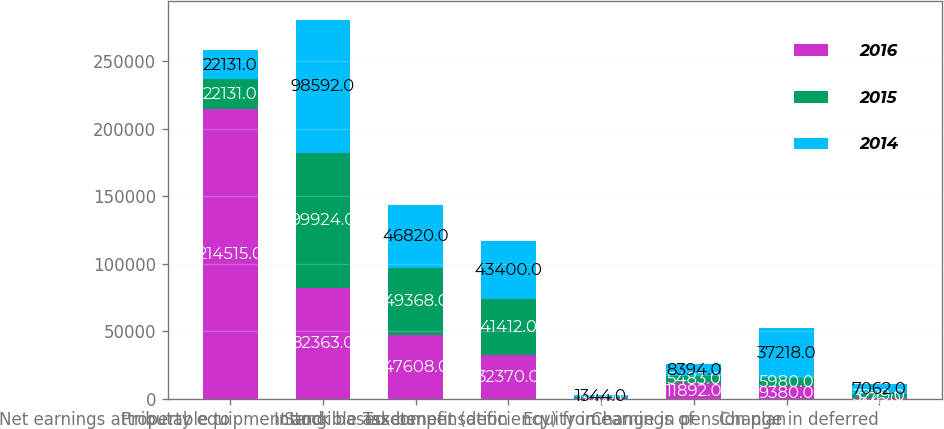<chart> <loc_0><loc_0><loc_500><loc_500><stacked_bar_chart><ecel><fcel>Net earnings attributable to<fcel>Property equipment and<fcel>Intangible assets<fcel>Stock based compensation<fcel>Tax benefit (deficiency) from<fcel>Equity in earnings of<fcel>Change in pension plan<fcel>Change in deferred<nl><fcel>2016<fcel>214515<fcel>82363<fcel>47608<fcel>32370<fcel>377<fcel>11892<fcel>9380<fcel>576<nl><fcel>2015<fcel>22131<fcel>99924<fcel>49368<fcel>41412<fcel>1237<fcel>5483<fcel>5980<fcel>3229<nl><fcel>2014<fcel>22131<fcel>98592<fcel>46820<fcel>43400<fcel>1344<fcel>8394<fcel>37218<fcel>7062<nl></chart> 